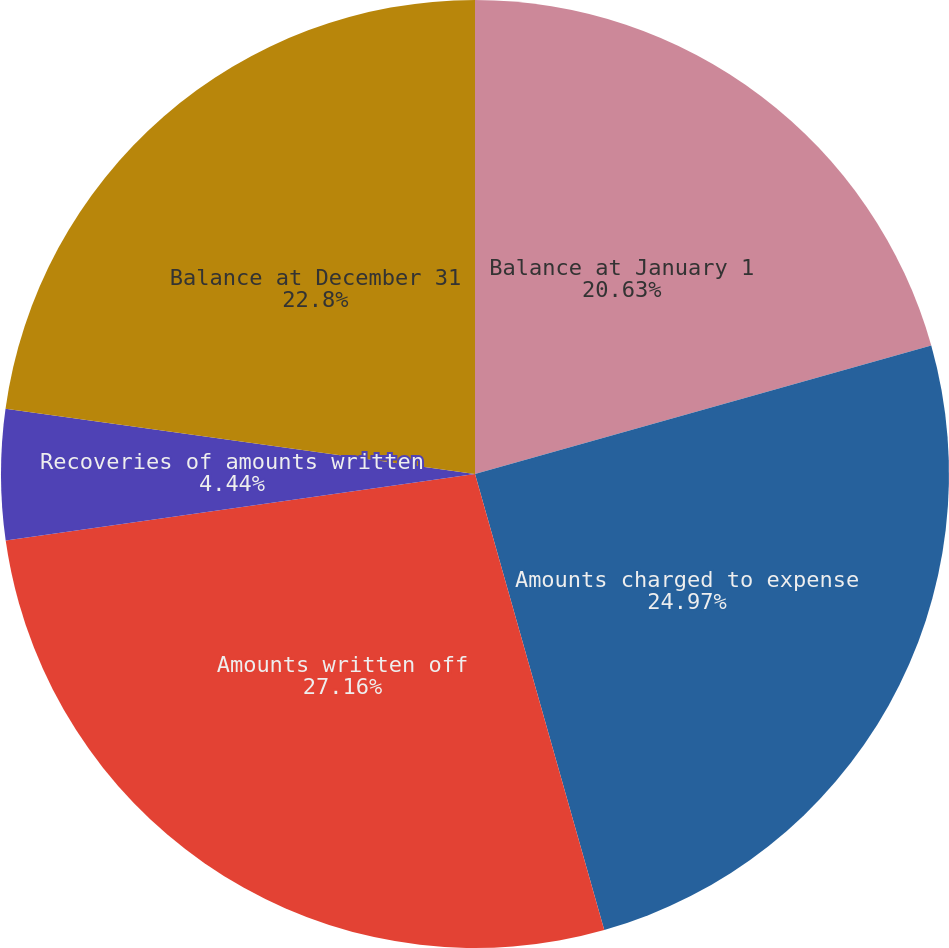Convert chart. <chart><loc_0><loc_0><loc_500><loc_500><pie_chart><fcel>Balance at January 1<fcel>Amounts charged to expense<fcel>Amounts written off<fcel>Recoveries of amounts written<fcel>Balance at December 31<nl><fcel>20.63%<fcel>24.97%<fcel>27.15%<fcel>4.44%<fcel>22.8%<nl></chart> 